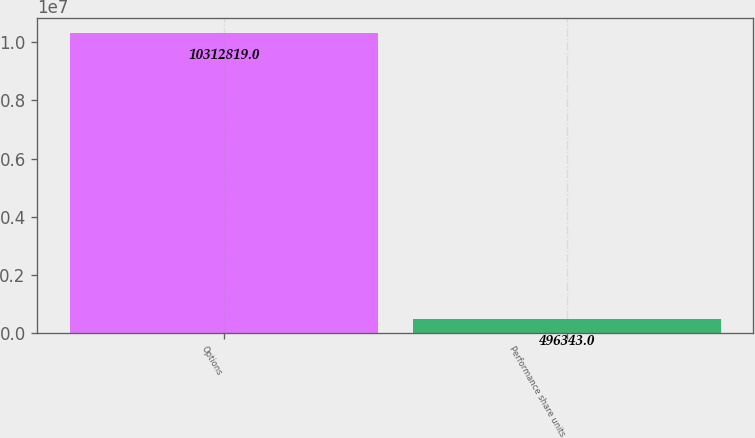Convert chart. <chart><loc_0><loc_0><loc_500><loc_500><bar_chart><fcel>Options<fcel>Performance share units<nl><fcel>1.03128e+07<fcel>496343<nl></chart> 